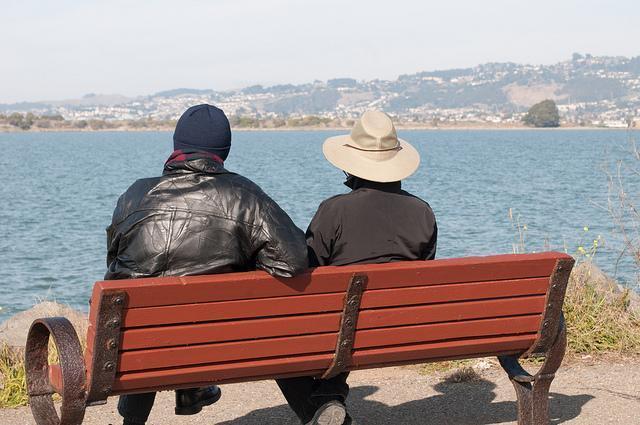How many people are seated?
Give a very brief answer. 2. How many people are there?
Give a very brief answer. 2. 